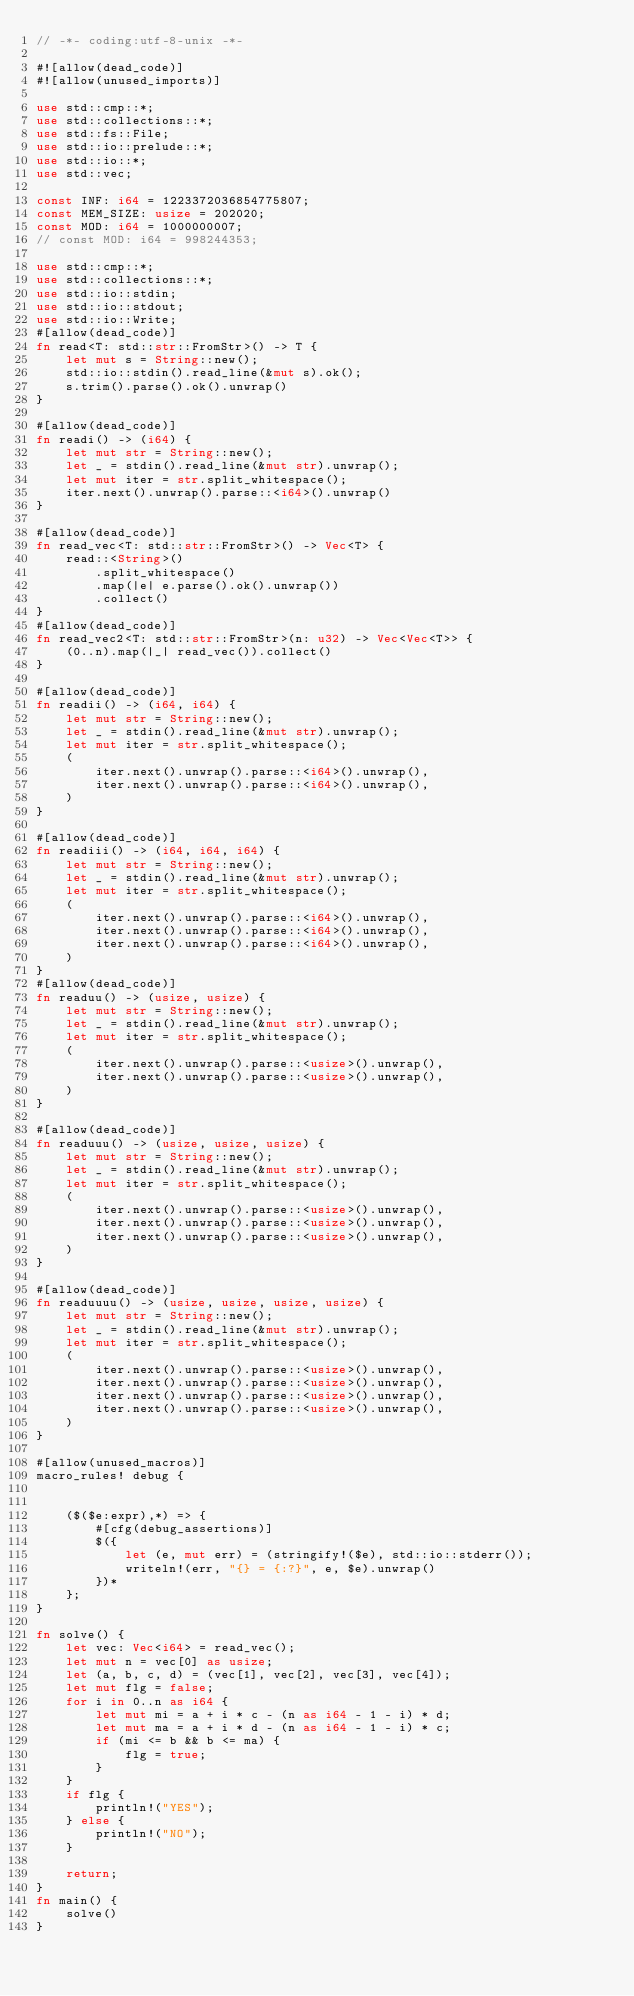<code> <loc_0><loc_0><loc_500><loc_500><_Rust_>// -*- coding:utf-8-unix -*-

#![allow(dead_code)]
#![allow(unused_imports)]

use std::cmp::*;
use std::collections::*;
use std::fs::File;
use std::io::prelude::*;
use std::io::*;
use std::vec;

const INF: i64 = 1223372036854775807;
const MEM_SIZE: usize = 202020;
const MOD: i64 = 1000000007;
// const MOD: i64 = 998244353;

use std::cmp::*;
use std::collections::*;
use std::io::stdin;
use std::io::stdout;
use std::io::Write;
#[allow(dead_code)]
fn read<T: std::str::FromStr>() -> T {
    let mut s = String::new();
    std::io::stdin().read_line(&mut s).ok();
    s.trim().parse().ok().unwrap()
}

#[allow(dead_code)]
fn readi() -> (i64) {
    let mut str = String::new();
    let _ = stdin().read_line(&mut str).unwrap();
    let mut iter = str.split_whitespace();
    iter.next().unwrap().parse::<i64>().unwrap()
}

#[allow(dead_code)]
fn read_vec<T: std::str::FromStr>() -> Vec<T> {
    read::<String>()
        .split_whitespace()
        .map(|e| e.parse().ok().unwrap())
        .collect()
}
#[allow(dead_code)]
fn read_vec2<T: std::str::FromStr>(n: u32) -> Vec<Vec<T>> {
    (0..n).map(|_| read_vec()).collect()
}

#[allow(dead_code)]
fn readii() -> (i64, i64) {
    let mut str = String::new();
    let _ = stdin().read_line(&mut str).unwrap();
    let mut iter = str.split_whitespace();
    (
        iter.next().unwrap().parse::<i64>().unwrap(),
        iter.next().unwrap().parse::<i64>().unwrap(),
    )
}

#[allow(dead_code)]
fn readiii() -> (i64, i64, i64) {
    let mut str = String::new();
    let _ = stdin().read_line(&mut str).unwrap();
    let mut iter = str.split_whitespace();
    (
        iter.next().unwrap().parse::<i64>().unwrap(),
        iter.next().unwrap().parse::<i64>().unwrap(),
        iter.next().unwrap().parse::<i64>().unwrap(),
    )
}
#[allow(dead_code)]
fn readuu() -> (usize, usize) {
    let mut str = String::new();
    let _ = stdin().read_line(&mut str).unwrap();
    let mut iter = str.split_whitespace();
    (
        iter.next().unwrap().parse::<usize>().unwrap(),
        iter.next().unwrap().parse::<usize>().unwrap(),
    )
}

#[allow(dead_code)]
fn readuuu() -> (usize, usize, usize) {
    let mut str = String::new();
    let _ = stdin().read_line(&mut str).unwrap();
    let mut iter = str.split_whitespace();
    (
        iter.next().unwrap().parse::<usize>().unwrap(),
        iter.next().unwrap().parse::<usize>().unwrap(),
        iter.next().unwrap().parse::<usize>().unwrap(),
    )
}

#[allow(dead_code)]
fn readuuuu() -> (usize, usize, usize, usize) {
    let mut str = String::new();
    let _ = stdin().read_line(&mut str).unwrap();
    let mut iter = str.split_whitespace();
    (
        iter.next().unwrap().parse::<usize>().unwrap(),
        iter.next().unwrap().parse::<usize>().unwrap(),
        iter.next().unwrap().parse::<usize>().unwrap(),
        iter.next().unwrap().parse::<usize>().unwrap(),
    )
}

#[allow(unused_macros)]
macro_rules! debug {


    ($($e:expr),*) => {
        #[cfg(debug_assertions)]
        $({
            let (e, mut err) = (stringify!($e), std::io::stderr());
            writeln!(err, "{} = {:?}", e, $e).unwrap()
        })*
    };
}

fn solve() {
    let vec: Vec<i64> = read_vec();
    let mut n = vec[0] as usize;
    let (a, b, c, d) = (vec[1], vec[2], vec[3], vec[4]);
    let mut flg = false;
    for i in 0..n as i64 {
        let mut mi = a + i * c - (n as i64 - 1 - i) * d;
        let mut ma = a + i * d - (n as i64 - 1 - i) * c;
        if (mi <= b && b <= ma) {
            flg = true;
        }
    }
    if flg {
        println!("YES");
    } else {
        println!("NO");
    }

    return;
}
fn main() {
    solve()
}
</code> 